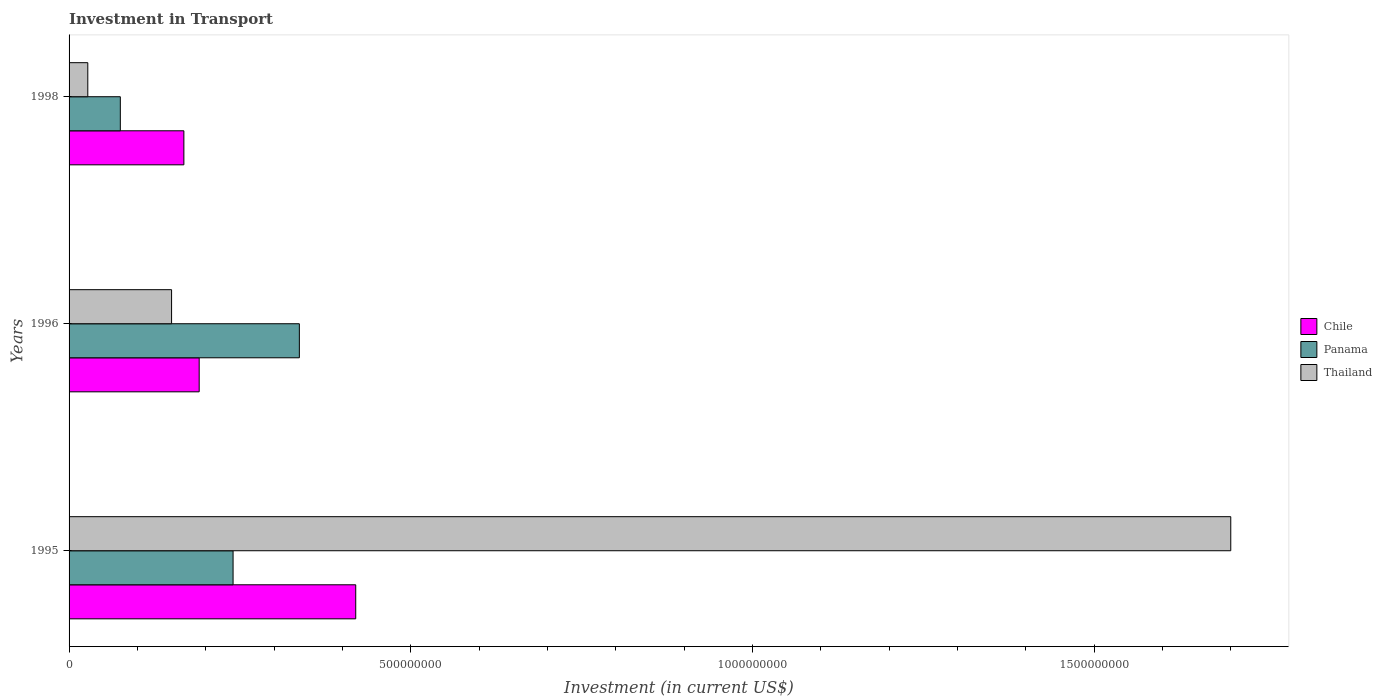Are the number of bars per tick equal to the number of legend labels?
Make the answer very short. Yes. Are the number of bars on each tick of the Y-axis equal?
Offer a very short reply. Yes. How many bars are there on the 2nd tick from the bottom?
Offer a very short reply. 3. What is the amount invested in transport in Panama in 1995?
Offer a very short reply. 2.40e+08. Across all years, what is the maximum amount invested in transport in Panama?
Offer a terse response. 3.37e+08. Across all years, what is the minimum amount invested in transport in Chile?
Give a very brief answer. 1.68e+08. What is the total amount invested in transport in Chile in the graph?
Your response must be concise. 7.78e+08. What is the difference between the amount invested in transport in Chile in 1996 and that in 1998?
Your answer should be compact. 2.24e+07. What is the difference between the amount invested in transport in Panama in 1996 and the amount invested in transport in Chile in 1995?
Your response must be concise. -8.25e+07. What is the average amount invested in transport in Panama per year?
Your answer should be compact. 2.17e+08. In the year 1995, what is the difference between the amount invested in transport in Panama and amount invested in transport in Thailand?
Offer a terse response. -1.46e+09. In how many years, is the amount invested in transport in Thailand greater than 1000000000 US$?
Your response must be concise. 1. What is the ratio of the amount invested in transport in Panama in 1996 to that in 1998?
Ensure brevity in your answer.  4.49. Is the amount invested in transport in Panama in 1996 less than that in 1998?
Give a very brief answer. No. What is the difference between the highest and the second highest amount invested in transport in Chile?
Give a very brief answer. 2.29e+08. What is the difference between the highest and the lowest amount invested in transport in Thailand?
Make the answer very short. 1.67e+09. In how many years, is the amount invested in transport in Thailand greater than the average amount invested in transport in Thailand taken over all years?
Provide a short and direct response. 1. What does the 1st bar from the top in 1995 represents?
Offer a terse response. Thailand. What does the 3rd bar from the bottom in 1998 represents?
Keep it short and to the point. Thailand. Are the values on the major ticks of X-axis written in scientific E-notation?
Your response must be concise. No. Does the graph contain any zero values?
Give a very brief answer. No. Where does the legend appear in the graph?
Ensure brevity in your answer.  Center right. How many legend labels are there?
Your answer should be compact. 3. What is the title of the graph?
Offer a very short reply. Investment in Transport. Does "Zimbabwe" appear as one of the legend labels in the graph?
Ensure brevity in your answer.  No. What is the label or title of the X-axis?
Your answer should be compact. Investment (in current US$). What is the label or title of the Y-axis?
Give a very brief answer. Years. What is the Investment (in current US$) of Chile in 1995?
Keep it short and to the point. 4.20e+08. What is the Investment (in current US$) of Panama in 1995?
Offer a very short reply. 2.40e+08. What is the Investment (in current US$) of Thailand in 1995?
Your answer should be very brief. 1.70e+09. What is the Investment (in current US$) in Chile in 1996?
Your response must be concise. 1.90e+08. What is the Investment (in current US$) in Panama in 1996?
Your answer should be compact. 3.37e+08. What is the Investment (in current US$) in Thailand in 1996?
Your response must be concise. 1.50e+08. What is the Investment (in current US$) in Chile in 1998?
Give a very brief answer. 1.68e+08. What is the Investment (in current US$) in Panama in 1998?
Your answer should be compact. 7.50e+07. What is the Investment (in current US$) in Thailand in 1998?
Make the answer very short. 2.74e+07. Across all years, what is the maximum Investment (in current US$) in Chile?
Ensure brevity in your answer.  4.20e+08. Across all years, what is the maximum Investment (in current US$) in Panama?
Your response must be concise. 3.37e+08. Across all years, what is the maximum Investment (in current US$) in Thailand?
Provide a short and direct response. 1.70e+09. Across all years, what is the minimum Investment (in current US$) of Chile?
Ensure brevity in your answer.  1.68e+08. Across all years, what is the minimum Investment (in current US$) in Panama?
Offer a very short reply. 7.50e+07. Across all years, what is the minimum Investment (in current US$) in Thailand?
Your response must be concise. 2.74e+07. What is the total Investment (in current US$) of Chile in the graph?
Offer a very short reply. 7.78e+08. What is the total Investment (in current US$) in Panama in the graph?
Ensure brevity in your answer.  6.52e+08. What is the total Investment (in current US$) in Thailand in the graph?
Ensure brevity in your answer.  1.88e+09. What is the difference between the Investment (in current US$) of Chile in 1995 and that in 1996?
Provide a short and direct response. 2.29e+08. What is the difference between the Investment (in current US$) of Panama in 1995 and that in 1996?
Your response must be concise. -9.70e+07. What is the difference between the Investment (in current US$) in Thailand in 1995 and that in 1996?
Your answer should be compact. 1.55e+09. What is the difference between the Investment (in current US$) in Chile in 1995 and that in 1998?
Provide a succinct answer. 2.52e+08. What is the difference between the Investment (in current US$) of Panama in 1995 and that in 1998?
Offer a very short reply. 1.65e+08. What is the difference between the Investment (in current US$) of Thailand in 1995 and that in 1998?
Ensure brevity in your answer.  1.67e+09. What is the difference between the Investment (in current US$) of Chile in 1996 and that in 1998?
Your answer should be compact. 2.24e+07. What is the difference between the Investment (in current US$) in Panama in 1996 and that in 1998?
Offer a very short reply. 2.62e+08. What is the difference between the Investment (in current US$) in Thailand in 1996 and that in 1998?
Ensure brevity in your answer.  1.23e+08. What is the difference between the Investment (in current US$) in Chile in 1995 and the Investment (in current US$) in Panama in 1996?
Ensure brevity in your answer.  8.25e+07. What is the difference between the Investment (in current US$) in Chile in 1995 and the Investment (in current US$) in Thailand in 1996?
Your response must be concise. 2.70e+08. What is the difference between the Investment (in current US$) in Panama in 1995 and the Investment (in current US$) in Thailand in 1996?
Your answer should be compact. 9.00e+07. What is the difference between the Investment (in current US$) in Chile in 1995 and the Investment (in current US$) in Panama in 1998?
Ensure brevity in your answer.  3.44e+08. What is the difference between the Investment (in current US$) in Chile in 1995 and the Investment (in current US$) in Thailand in 1998?
Your response must be concise. 3.92e+08. What is the difference between the Investment (in current US$) in Panama in 1995 and the Investment (in current US$) in Thailand in 1998?
Provide a succinct answer. 2.13e+08. What is the difference between the Investment (in current US$) of Chile in 1996 and the Investment (in current US$) of Panama in 1998?
Your answer should be compact. 1.15e+08. What is the difference between the Investment (in current US$) in Chile in 1996 and the Investment (in current US$) in Thailand in 1998?
Offer a terse response. 1.63e+08. What is the difference between the Investment (in current US$) of Panama in 1996 and the Investment (in current US$) of Thailand in 1998?
Make the answer very short. 3.10e+08. What is the average Investment (in current US$) in Chile per year?
Your answer should be very brief. 2.59e+08. What is the average Investment (in current US$) in Panama per year?
Keep it short and to the point. 2.17e+08. What is the average Investment (in current US$) in Thailand per year?
Your answer should be very brief. 6.26e+08. In the year 1995, what is the difference between the Investment (in current US$) in Chile and Investment (in current US$) in Panama?
Make the answer very short. 1.80e+08. In the year 1995, what is the difference between the Investment (in current US$) of Chile and Investment (in current US$) of Thailand?
Make the answer very short. -1.28e+09. In the year 1995, what is the difference between the Investment (in current US$) of Panama and Investment (in current US$) of Thailand?
Offer a terse response. -1.46e+09. In the year 1996, what is the difference between the Investment (in current US$) in Chile and Investment (in current US$) in Panama?
Your answer should be very brief. -1.47e+08. In the year 1996, what is the difference between the Investment (in current US$) of Chile and Investment (in current US$) of Thailand?
Ensure brevity in your answer.  4.04e+07. In the year 1996, what is the difference between the Investment (in current US$) in Panama and Investment (in current US$) in Thailand?
Your answer should be compact. 1.87e+08. In the year 1998, what is the difference between the Investment (in current US$) of Chile and Investment (in current US$) of Panama?
Offer a very short reply. 9.30e+07. In the year 1998, what is the difference between the Investment (in current US$) of Chile and Investment (in current US$) of Thailand?
Provide a short and direct response. 1.41e+08. In the year 1998, what is the difference between the Investment (in current US$) in Panama and Investment (in current US$) in Thailand?
Make the answer very short. 4.76e+07. What is the ratio of the Investment (in current US$) of Chile in 1995 to that in 1996?
Your answer should be very brief. 2.2. What is the ratio of the Investment (in current US$) in Panama in 1995 to that in 1996?
Make the answer very short. 0.71. What is the ratio of the Investment (in current US$) of Thailand in 1995 to that in 1996?
Keep it short and to the point. 11.33. What is the ratio of the Investment (in current US$) in Chile in 1995 to that in 1998?
Provide a succinct answer. 2.5. What is the ratio of the Investment (in current US$) in Panama in 1995 to that in 1998?
Offer a terse response. 3.2. What is the ratio of the Investment (in current US$) of Thailand in 1995 to that in 1998?
Provide a short and direct response. 62.04. What is the ratio of the Investment (in current US$) of Chile in 1996 to that in 1998?
Provide a short and direct response. 1.13. What is the ratio of the Investment (in current US$) in Panama in 1996 to that in 1998?
Provide a succinct answer. 4.49. What is the ratio of the Investment (in current US$) in Thailand in 1996 to that in 1998?
Make the answer very short. 5.47. What is the difference between the highest and the second highest Investment (in current US$) of Chile?
Provide a succinct answer. 2.29e+08. What is the difference between the highest and the second highest Investment (in current US$) of Panama?
Your answer should be compact. 9.70e+07. What is the difference between the highest and the second highest Investment (in current US$) in Thailand?
Ensure brevity in your answer.  1.55e+09. What is the difference between the highest and the lowest Investment (in current US$) in Chile?
Give a very brief answer. 2.52e+08. What is the difference between the highest and the lowest Investment (in current US$) of Panama?
Provide a short and direct response. 2.62e+08. What is the difference between the highest and the lowest Investment (in current US$) in Thailand?
Your answer should be compact. 1.67e+09. 